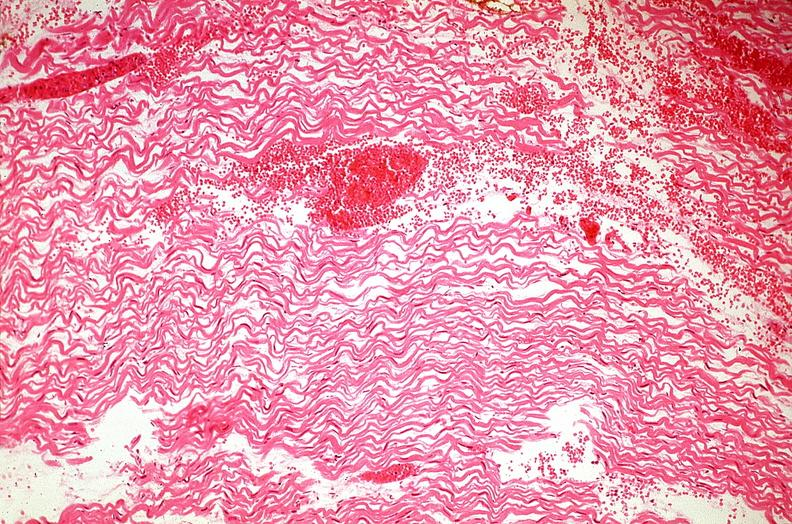s cardiovascular present?
Answer the question using a single word or phrase. Yes 